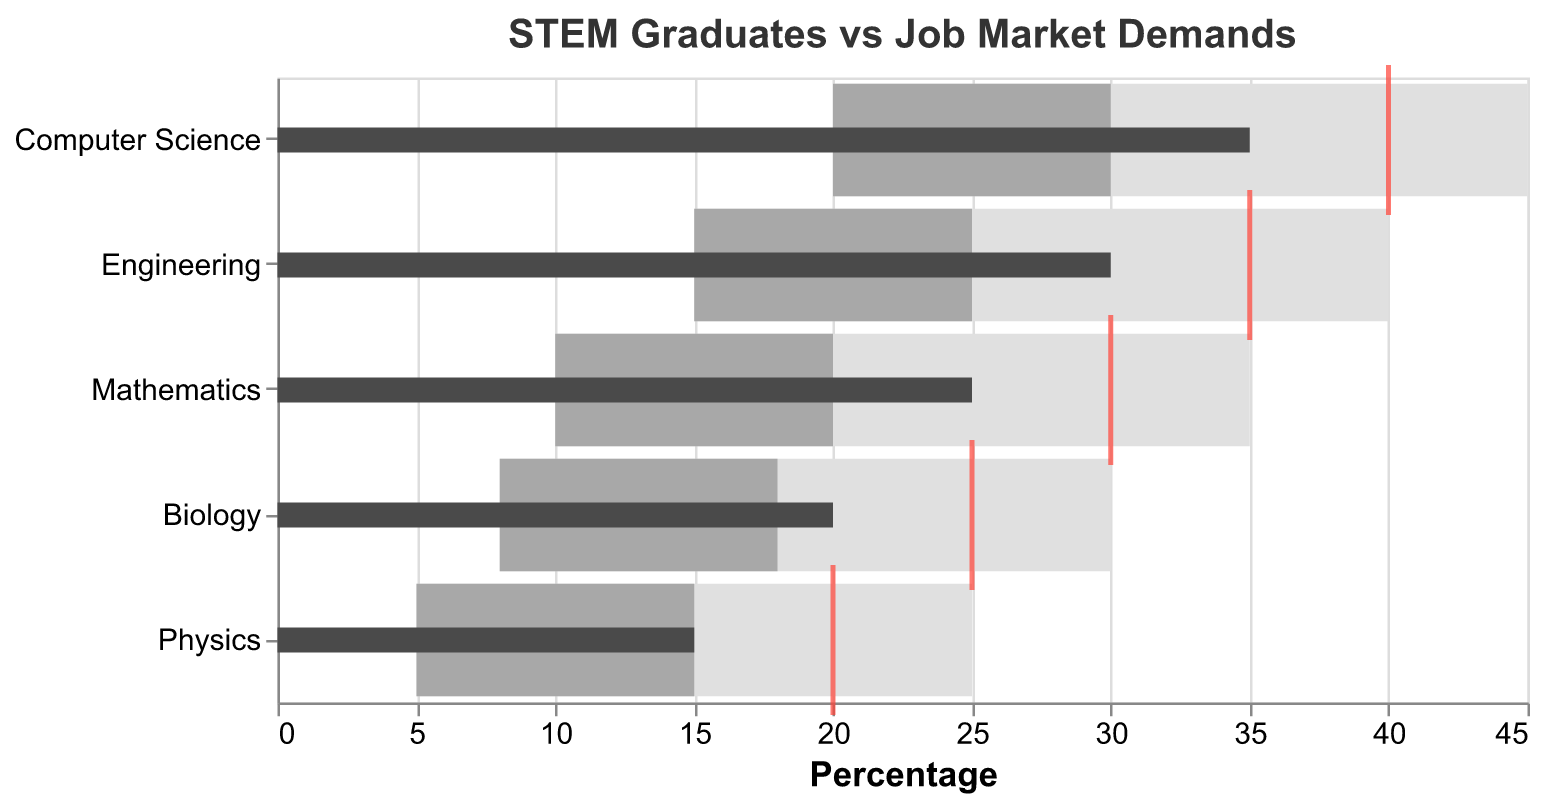What is the title of the chart? The title can be found at the top of the chart and provides a summary of what the chart is about.
Answer: STEM Graduates vs Job Market Demands Which STEM category has the highest number of actual graduates? By examining the height of the dark gray bars across all categories, one can determine which category has the highest value.
Answer: Computer Science Are the actual number of graduates for any category exactly meeting the target? Compare the position of the red tick marks (targets) with the dark gray bars (actual number of graduates) for each category to see if they align.
Answer: No How far is the actual number of Biology graduates from its target? Subtract the actual number of Biology graduates from its target (25 - 20).
Answer: 5 Which STEM category is performing the worst compared to its target? Identify the category where the actual value (dark gray bar) is furthest from its target (red tick mark), looking for the largest negative gap.
Answer: Physics What is the range defined as 'Good' for Engineering graduates? The range can be determined by the 'Good' value for Engineering and the 'Poor' value. Subtract Poor value (15) from Good value (40).
Answer: 25 Are the actual number of graduates in Mathematics within the 'Satisfactory' range? Check if the actual value of Mathematics (25) lies between the 'Poor' (10) and 'Satisfactory' (20) ranges.
Answer: Yes, exceeds satisfactory Which categories have actual graduates in the 'Good' range? Look for categories where the actual number of graduates (dark gray bars) fall within the 'Good' section (from Poor value to Good value).
Answer: None Which STEM field has the smallest difference between actual and target number of graduates? Calculate the difference between actual and target for all categories and identify the smallest difference.
Answer: Biology 